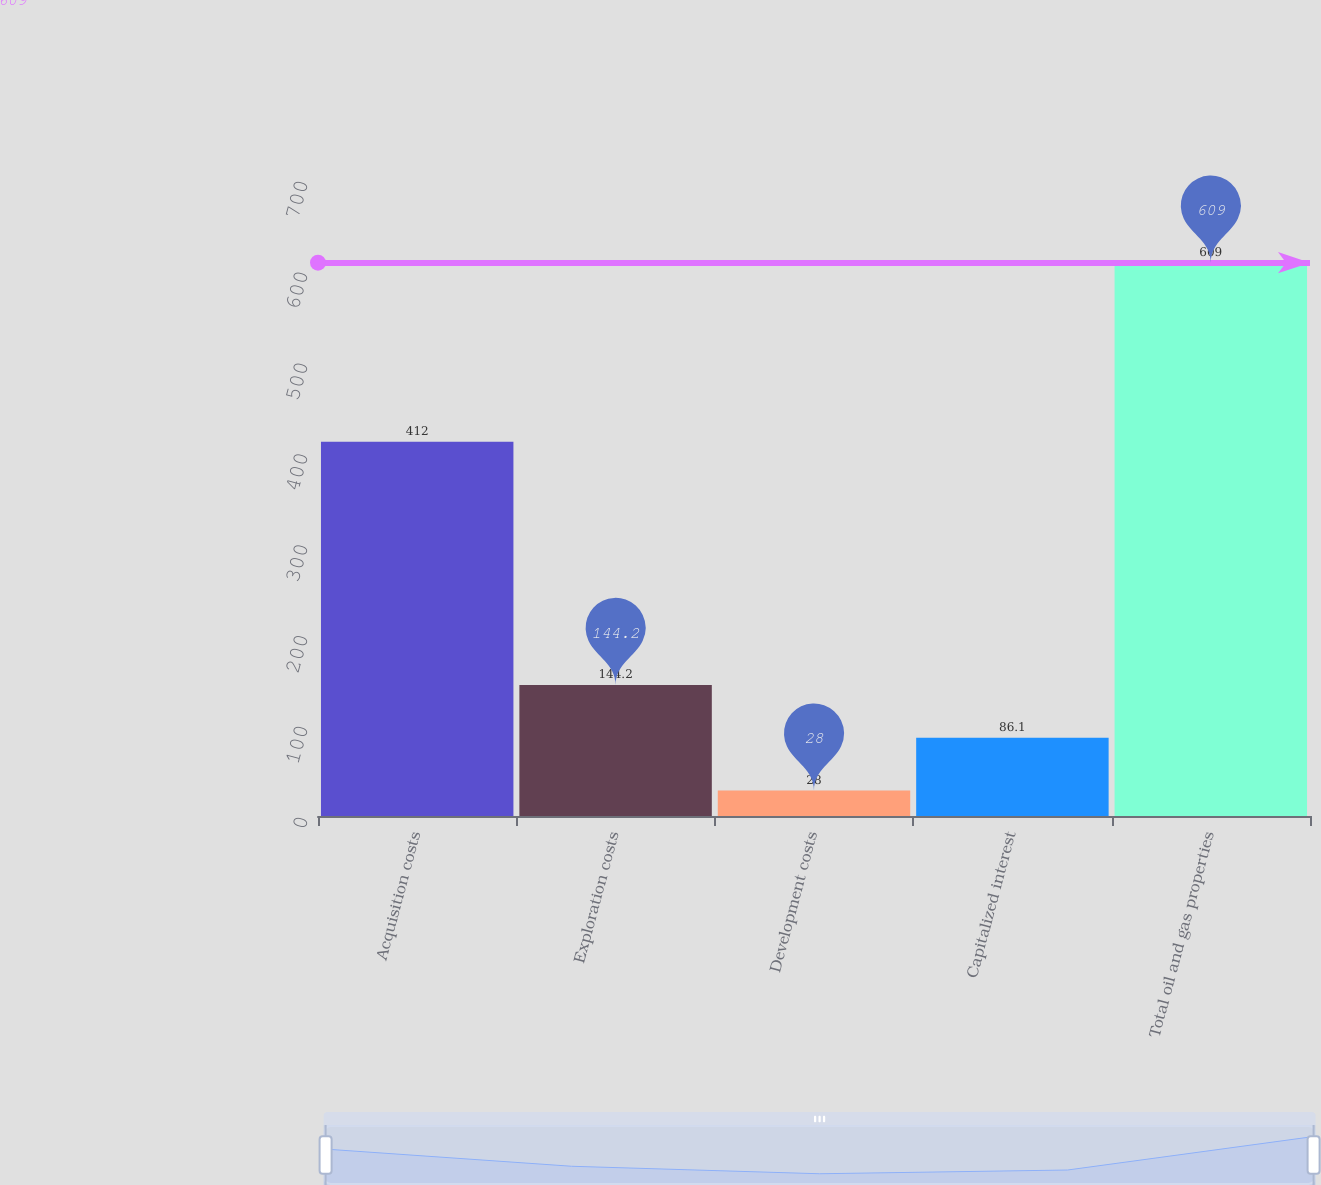<chart> <loc_0><loc_0><loc_500><loc_500><bar_chart><fcel>Acquisition costs<fcel>Exploration costs<fcel>Development costs<fcel>Capitalized interest<fcel>Total oil and gas properties<nl><fcel>412<fcel>144.2<fcel>28<fcel>86.1<fcel>609<nl></chart> 